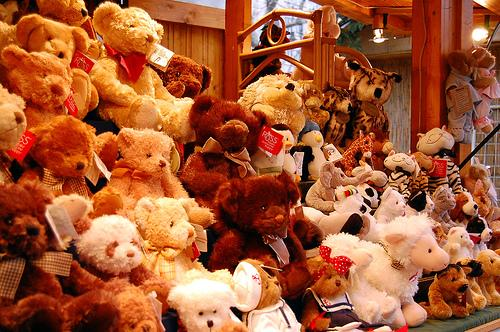Explain one object interaction occurring in the image. A bear has a red bow on its head, which indicates that it is interacting with the bow as an accessory. What do the stuffed animals in the image seem to be arranged for? For display, as they are many stuffed toys arranged together. Estimate how many teddy bears are mentioned in the text. At least 14 teddy bears are mentioned in the text. If the image quality task discovered blurriness, list two distinct objects it might be difficult to perceive. The small toy elephant and the red and white bow on bears head might be difficult to perceive if the image is blurry. Mention the clothing or accessories that some of the objects in the image are wearing. Pink dress, red and white bows, sailor outfit, checkered tie, tiger-like stripes. What is the overall sentiment in the image? Joyful, as it shows various stuffed animals that typically bring comfort and happiness. Enumerate two objects having distinctive features. The spotted owl and the bear with a polka dot bow on its head. Identify the primary colors of the animals and list them. White, brown, light brown, black, and spotted. 